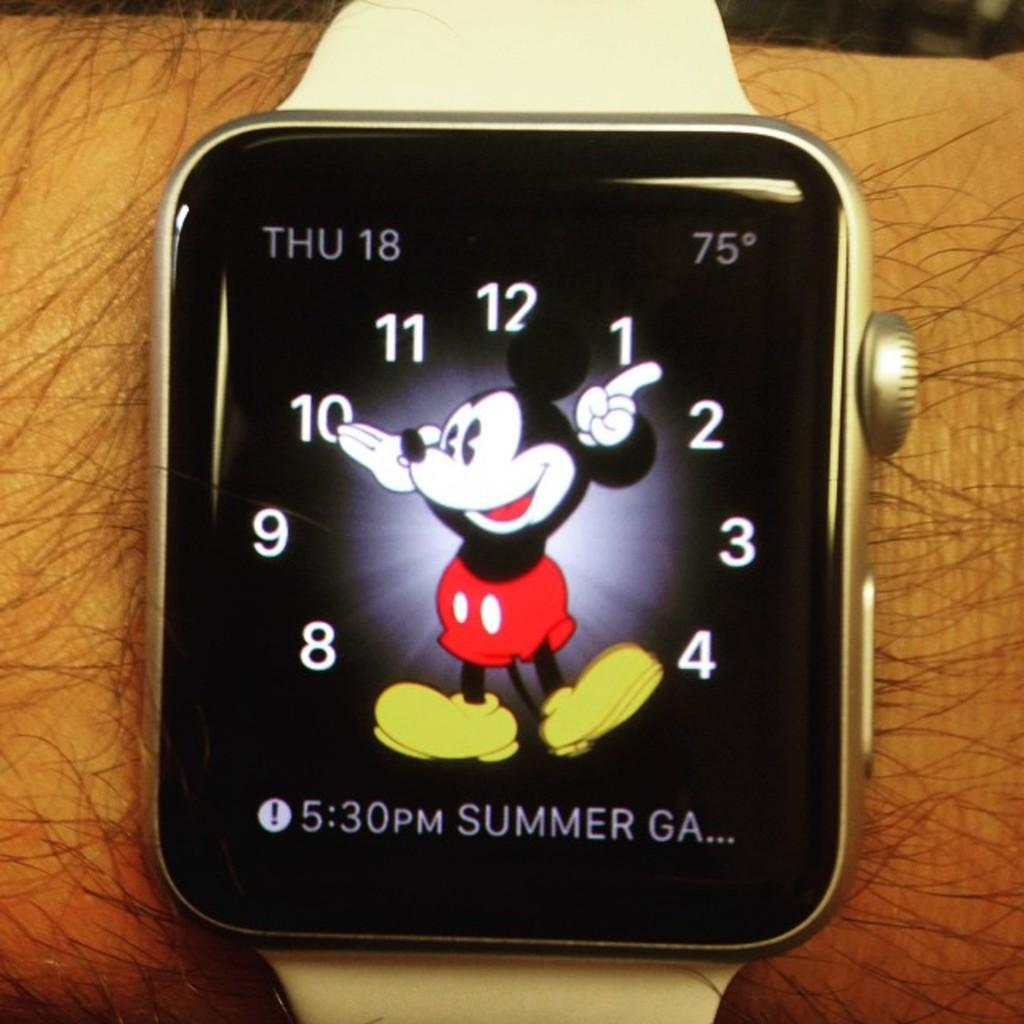<image>
Share a concise interpretation of the image provided. Person wearing a wristwatch that says the summer games start at 5:30. 